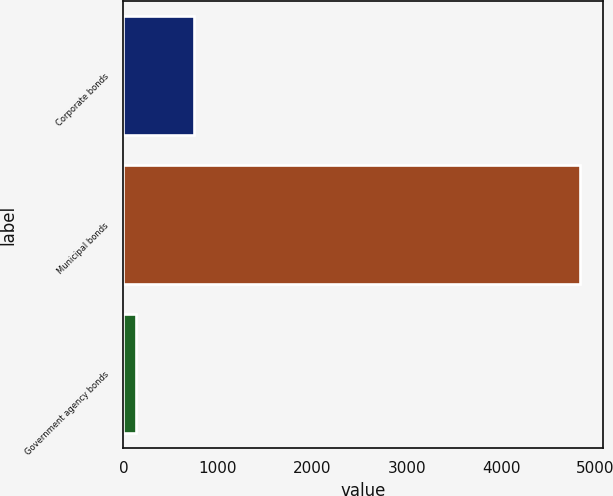Convert chart. <chart><loc_0><loc_0><loc_500><loc_500><bar_chart><fcel>Corporate bonds<fcel>Municipal bonds<fcel>Government agency bonds<nl><fcel>747<fcel>4837<fcel>132<nl></chart> 